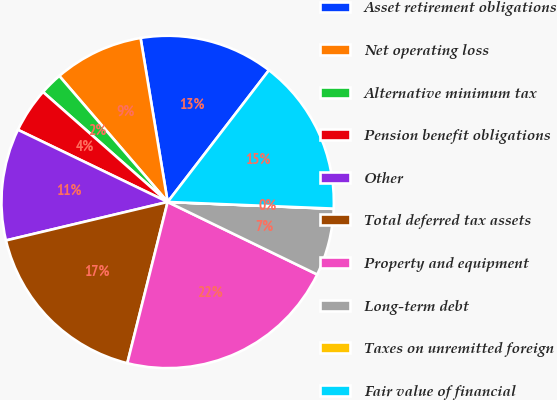Convert chart. <chart><loc_0><loc_0><loc_500><loc_500><pie_chart><fcel>Asset retirement obligations<fcel>Net operating loss<fcel>Alternative minimum tax<fcel>Pension benefit obligations<fcel>Other<fcel>Total deferred tax assets<fcel>Property and equipment<fcel>Long-term debt<fcel>Taxes on unremitted foreign<fcel>Fair value of financial<nl><fcel>13.04%<fcel>8.7%<fcel>2.19%<fcel>4.36%<fcel>10.87%<fcel>17.38%<fcel>21.72%<fcel>6.53%<fcel>0.02%<fcel>15.21%<nl></chart> 